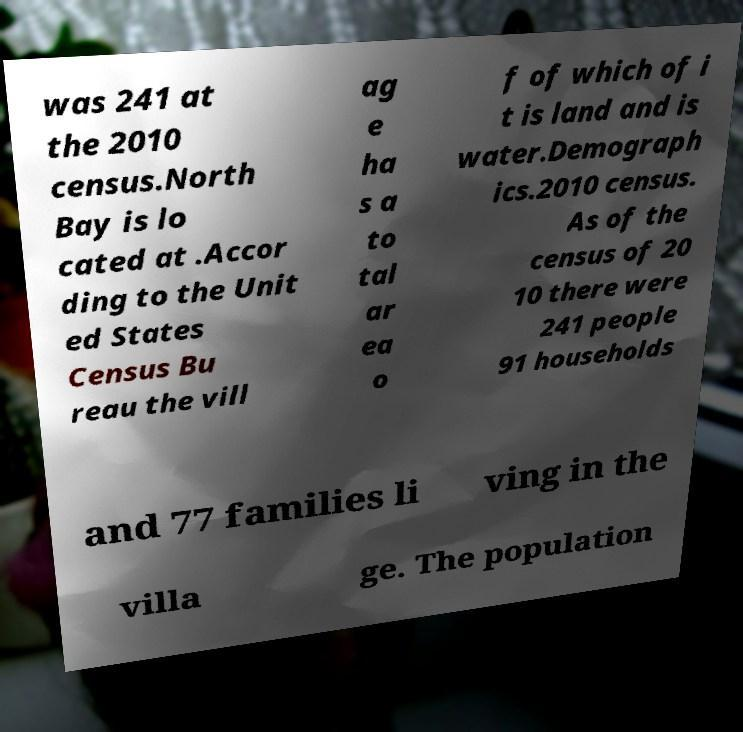I need the written content from this picture converted into text. Can you do that? was 241 at the 2010 census.North Bay is lo cated at .Accor ding to the Unit ed States Census Bu reau the vill ag e ha s a to tal ar ea o f of which of i t is land and is water.Demograph ics.2010 census. As of the census of 20 10 there were 241 people 91 households and 77 families li ving in the villa ge. The population 